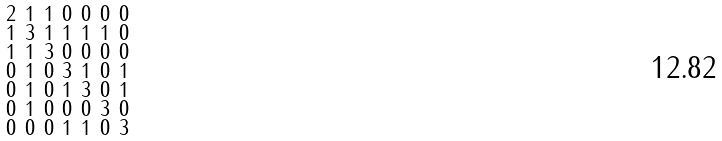Convert formula to latex. <formula><loc_0><loc_0><loc_500><loc_500>\begin{smallmatrix} 2 & 1 & 1 & 0 & 0 & 0 & 0 \\ 1 & 3 & 1 & 1 & 1 & 1 & 0 \\ 1 & 1 & 3 & 0 & 0 & 0 & 0 \\ 0 & 1 & 0 & 3 & 1 & 0 & 1 \\ 0 & 1 & 0 & 1 & 3 & 0 & 1 \\ 0 & 1 & 0 & 0 & 0 & 3 & 0 \\ 0 & 0 & 0 & 1 & 1 & 0 & 3 \end{smallmatrix}</formula> 